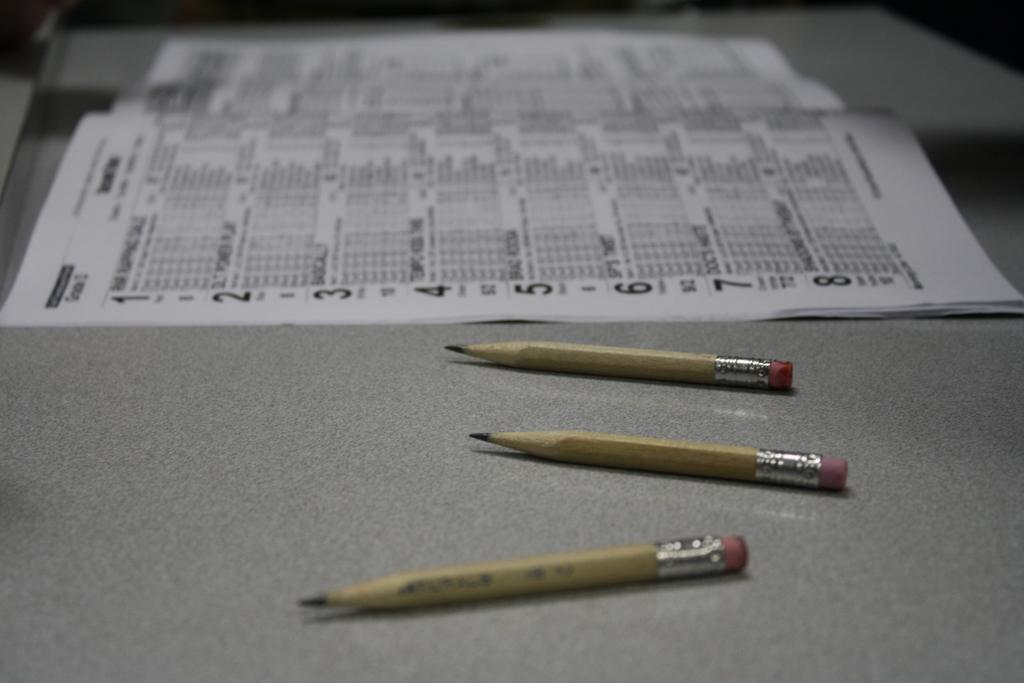Describe this image in one or two sentences. In this picture we can see three brown pencils are placed on the grey color table top. Beside we can see calendar paper placed on the same table top. 